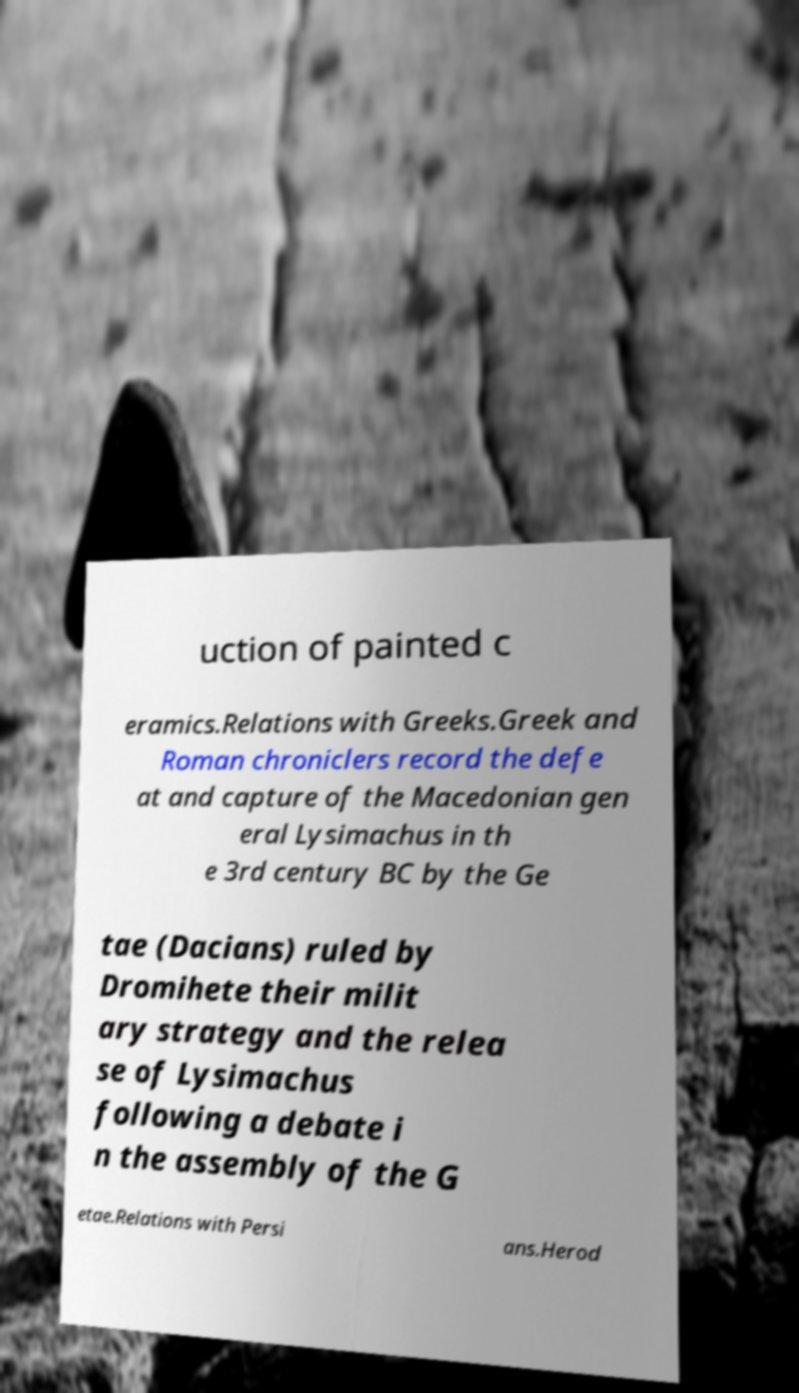Could you assist in decoding the text presented in this image and type it out clearly? uction of painted c eramics.Relations with Greeks.Greek and Roman chroniclers record the defe at and capture of the Macedonian gen eral Lysimachus in th e 3rd century BC by the Ge tae (Dacians) ruled by Dromihete their milit ary strategy and the relea se of Lysimachus following a debate i n the assembly of the G etae.Relations with Persi ans.Herod 